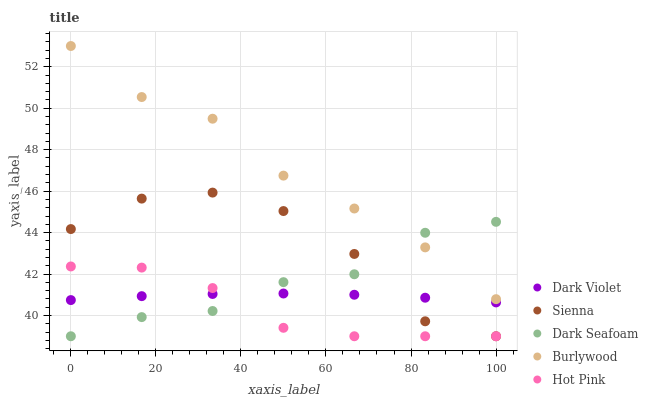Does Hot Pink have the minimum area under the curve?
Answer yes or no. Yes. Does Burlywood have the maximum area under the curve?
Answer yes or no. Yes. Does Dark Seafoam have the minimum area under the curve?
Answer yes or no. No. Does Dark Seafoam have the maximum area under the curve?
Answer yes or no. No. Is Dark Violet the smoothest?
Answer yes or no. Yes. Is Sienna the roughest?
Answer yes or no. Yes. Is Burlywood the smoothest?
Answer yes or no. No. Is Burlywood the roughest?
Answer yes or no. No. Does Sienna have the lowest value?
Answer yes or no. Yes. Does Burlywood have the lowest value?
Answer yes or no. No. Does Burlywood have the highest value?
Answer yes or no. Yes. Does Dark Seafoam have the highest value?
Answer yes or no. No. Is Hot Pink less than Burlywood?
Answer yes or no. Yes. Is Burlywood greater than Dark Violet?
Answer yes or no. Yes. Does Hot Pink intersect Dark Violet?
Answer yes or no. Yes. Is Hot Pink less than Dark Violet?
Answer yes or no. No. Is Hot Pink greater than Dark Violet?
Answer yes or no. No. Does Hot Pink intersect Burlywood?
Answer yes or no. No. 